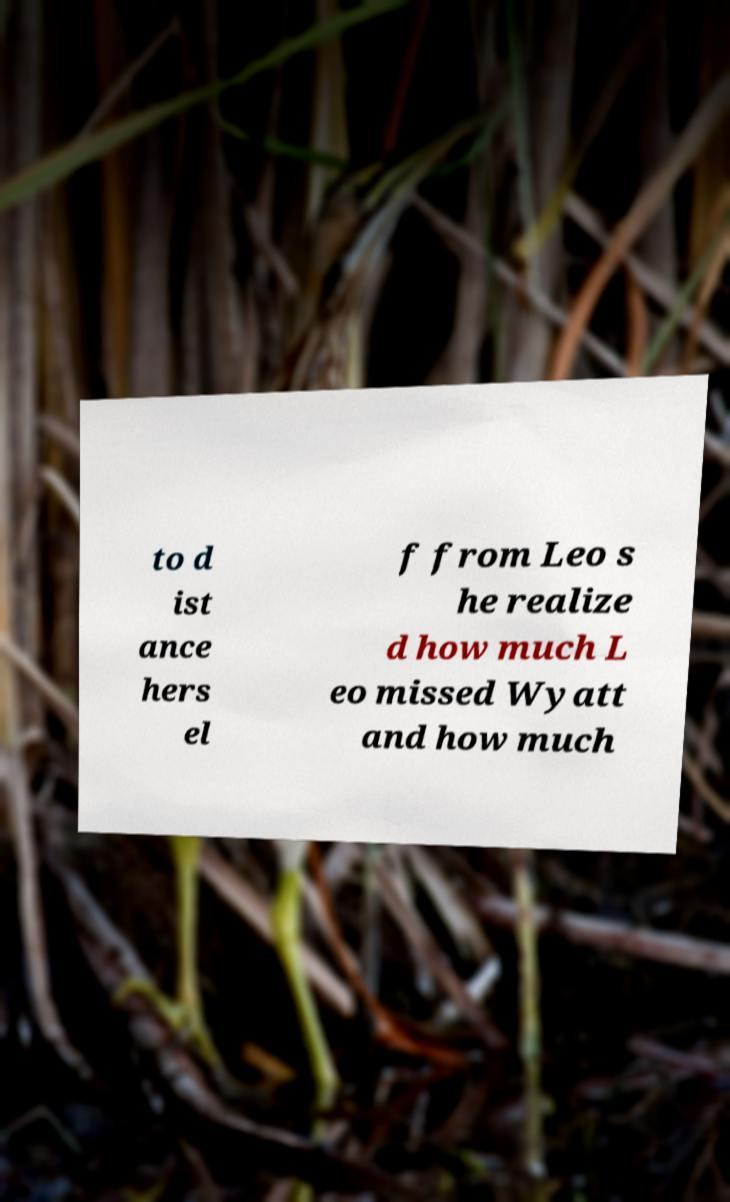Could you assist in decoding the text presented in this image and type it out clearly? to d ist ance hers el f from Leo s he realize d how much L eo missed Wyatt and how much 